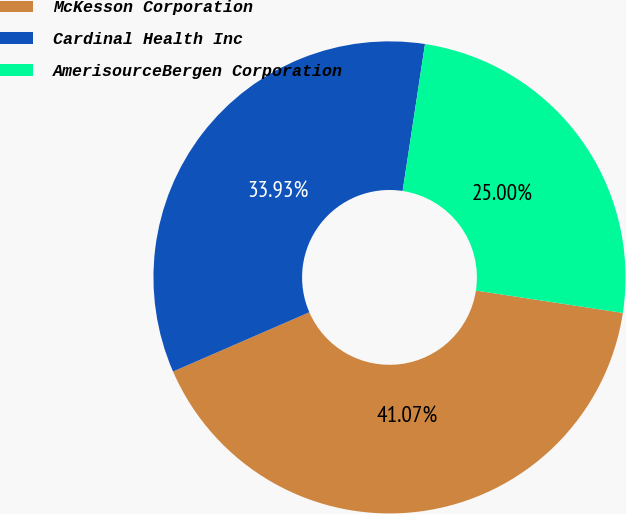<chart> <loc_0><loc_0><loc_500><loc_500><pie_chart><fcel>McKesson Corporation<fcel>Cardinal Health Inc<fcel>AmerisourceBergen Corporation<nl><fcel>41.07%<fcel>33.93%<fcel>25.0%<nl></chart> 